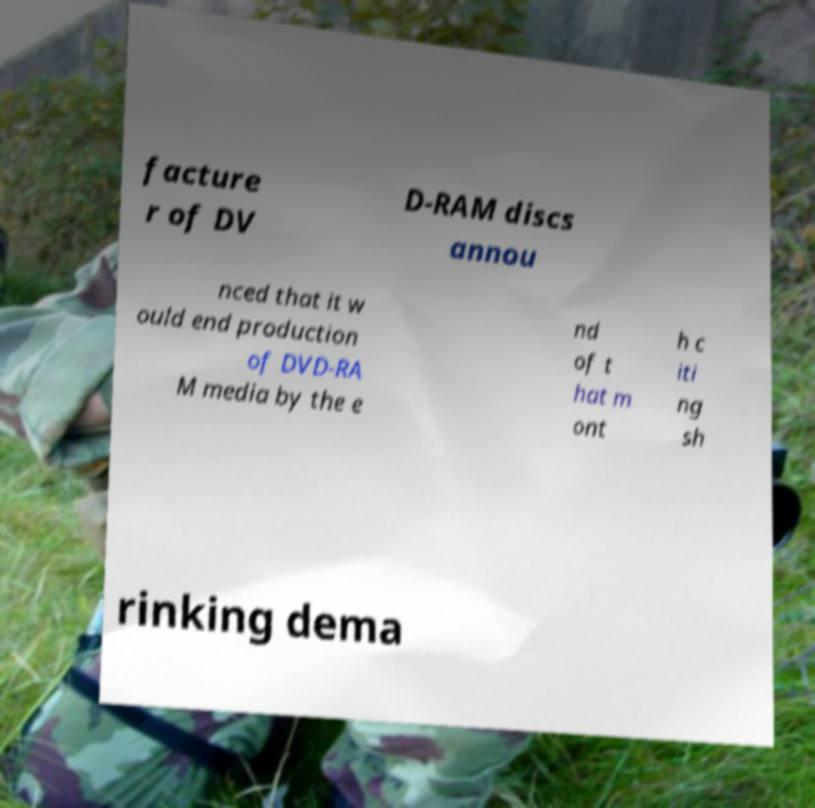For documentation purposes, I need the text within this image transcribed. Could you provide that? facture r of DV D-RAM discs annou nced that it w ould end production of DVD-RA M media by the e nd of t hat m ont h c iti ng sh rinking dema 